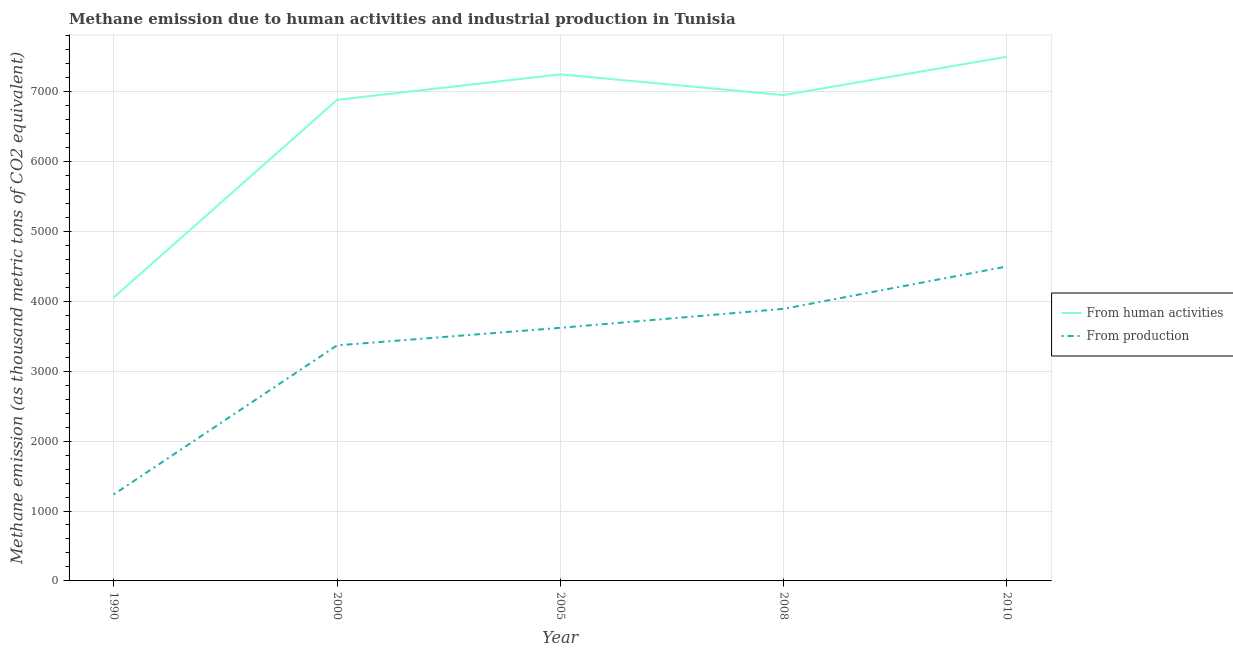What is the amount of emissions generated from industries in 2010?
Give a very brief answer. 4497.8. Across all years, what is the maximum amount of emissions generated from industries?
Give a very brief answer. 4497.8. Across all years, what is the minimum amount of emissions generated from industries?
Give a very brief answer. 1237. In which year was the amount of emissions from human activities maximum?
Your answer should be very brief. 2010. In which year was the amount of emissions from human activities minimum?
Make the answer very short. 1990. What is the total amount of emissions generated from industries in the graph?
Keep it short and to the point. 1.66e+04. What is the difference between the amount of emissions from human activities in 1990 and that in 2010?
Make the answer very short. -3442.5. What is the difference between the amount of emissions from human activities in 2010 and the amount of emissions generated from industries in 2005?
Provide a short and direct response. 3877.2. What is the average amount of emissions generated from industries per year?
Your response must be concise. 3323.08. In the year 2000, what is the difference between the amount of emissions from human activities and amount of emissions generated from industries?
Offer a terse response. 3511.7. In how many years, is the amount of emissions from human activities greater than 1800 thousand metric tons?
Your response must be concise. 5. What is the ratio of the amount of emissions generated from industries in 2005 to that in 2010?
Give a very brief answer. 0.8. What is the difference between the highest and the second highest amount of emissions from human activities?
Give a very brief answer. 251.9. What is the difference between the highest and the lowest amount of emissions from human activities?
Offer a terse response. 3442.5. Is the sum of the amount of emissions from human activities in 1990 and 2010 greater than the maximum amount of emissions generated from industries across all years?
Offer a very short reply. Yes. Is the amount of emissions generated from industries strictly less than the amount of emissions from human activities over the years?
Provide a short and direct response. Yes. What is the difference between two consecutive major ticks on the Y-axis?
Offer a terse response. 1000. Does the graph contain grids?
Your response must be concise. Yes. What is the title of the graph?
Your answer should be very brief. Methane emission due to human activities and industrial production in Tunisia. Does "Passenger Transport Items" appear as one of the legend labels in the graph?
Provide a short and direct response. No. What is the label or title of the Y-axis?
Your answer should be compact. Methane emission (as thousand metric tons of CO2 equivalent). What is the Methane emission (as thousand metric tons of CO2 equivalent) of From human activities in 1990?
Provide a short and direct response. 4054.8. What is the Methane emission (as thousand metric tons of CO2 equivalent) in From production in 1990?
Your answer should be compact. 1237. What is the Methane emission (as thousand metric tons of CO2 equivalent) in From human activities in 2000?
Offer a terse response. 6880.6. What is the Methane emission (as thousand metric tons of CO2 equivalent) in From production in 2000?
Offer a very short reply. 3368.9. What is the Methane emission (as thousand metric tons of CO2 equivalent) of From human activities in 2005?
Make the answer very short. 7245.4. What is the Methane emission (as thousand metric tons of CO2 equivalent) of From production in 2005?
Your answer should be very brief. 3620.1. What is the Methane emission (as thousand metric tons of CO2 equivalent) in From human activities in 2008?
Provide a short and direct response. 6949.3. What is the Methane emission (as thousand metric tons of CO2 equivalent) in From production in 2008?
Provide a short and direct response. 3891.6. What is the Methane emission (as thousand metric tons of CO2 equivalent) in From human activities in 2010?
Ensure brevity in your answer.  7497.3. What is the Methane emission (as thousand metric tons of CO2 equivalent) of From production in 2010?
Ensure brevity in your answer.  4497.8. Across all years, what is the maximum Methane emission (as thousand metric tons of CO2 equivalent) in From human activities?
Provide a short and direct response. 7497.3. Across all years, what is the maximum Methane emission (as thousand metric tons of CO2 equivalent) in From production?
Provide a short and direct response. 4497.8. Across all years, what is the minimum Methane emission (as thousand metric tons of CO2 equivalent) of From human activities?
Keep it short and to the point. 4054.8. Across all years, what is the minimum Methane emission (as thousand metric tons of CO2 equivalent) in From production?
Give a very brief answer. 1237. What is the total Methane emission (as thousand metric tons of CO2 equivalent) of From human activities in the graph?
Your answer should be compact. 3.26e+04. What is the total Methane emission (as thousand metric tons of CO2 equivalent) of From production in the graph?
Provide a short and direct response. 1.66e+04. What is the difference between the Methane emission (as thousand metric tons of CO2 equivalent) in From human activities in 1990 and that in 2000?
Your response must be concise. -2825.8. What is the difference between the Methane emission (as thousand metric tons of CO2 equivalent) in From production in 1990 and that in 2000?
Offer a very short reply. -2131.9. What is the difference between the Methane emission (as thousand metric tons of CO2 equivalent) in From human activities in 1990 and that in 2005?
Ensure brevity in your answer.  -3190.6. What is the difference between the Methane emission (as thousand metric tons of CO2 equivalent) of From production in 1990 and that in 2005?
Your answer should be compact. -2383.1. What is the difference between the Methane emission (as thousand metric tons of CO2 equivalent) of From human activities in 1990 and that in 2008?
Ensure brevity in your answer.  -2894.5. What is the difference between the Methane emission (as thousand metric tons of CO2 equivalent) in From production in 1990 and that in 2008?
Your answer should be compact. -2654.6. What is the difference between the Methane emission (as thousand metric tons of CO2 equivalent) of From human activities in 1990 and that in 2010?
Provide a short and direct response. -3442.5. What is the difference between the Methane emission (as thousand metric tons of CO2 equivalent) of From production in 1990 and that in 2010?
Give a very brief answer. -3260.8. What is the difference between the Methane emission (as thousand metric tons of CO2 equivalent) of From human activities in 2000 and that in 2005?
Provide a short and direct response. -364.8. What is the difference between the Methane emission (as thousand metric tons of CO2 equivalent) in From production in 2000 and that in 2005?
Your answer should be very brief. -251.2. What is the difference between the Methane emission (as thousand metric tons of CO2 equivalent) in From human activities in 2000 and that in 2008?
Your answer should be very brief. -68.7. What is the difference between the Methane emission (as thousand metric tons of CO2 equivalent) in From production in 2000 and that in 2008?
Your answer should be compact. -522.7. What is the difference between the Methane emission (as thousand metric tons of CO2 equivalent) in From human activities in 2000 and that in 2010?
Give a very brief answer. -616.7. What is the difference between the Methane emission (as thousand metric tons of CO2 equivalent) of From production in 2000 and that in 2010?
Provide a short and direct response. -1128.9. What is the difference between the Methane emission (as thousand metric tons of CO2 equivalent) of From human activities in 2005 and that in 2008?
Your answer should be compact. 296.1. What is the difference between the Methane emission (as thousand metric tons of CO2 equivalent) of From production in 2005 and that in 2008?
Provide a succinct answer. -271.5. What is the difference between the Methane emission (as thousand metric tons of CO2 equivalent) of From human activities in 2005 and that in 2010?
Make the answer very short. -251.9. What is the difference between the Methane emission (as thousand metric tons of CO2 equivalent) in From production in 2005 and that in 2010?
Offer a terse response. -877.7. What is the difference between the Methane emission (as thousand metric tons of CO2 equivalent) of From human activities in 2008 and that in 2010?
Your answer should be very brief. -548. What is the difference between the Methane emission (as thousand metric tons of CO2 equivalent) in From production in 2008 and that in 2010?
Ensure brevity in your answer.  -606.2. What is the difference between the Methane emission (as thousand metric tons of CO2 equivalent) of From human activities in 1990 and the Methane emission (as thousand metric tons of CO2 equivalent) of From production in 2000?
Give a very brief answer. 685.9. What is the difference between the Methane emission (as thousand metric tons of CO2 equivalent) in From human activities in 1990 and the Methane emission (as thousand metric tons of CO2 equivalent) in From production in 2005?
Your response must be concise. 434.7. What is the difference between the Methane emission (as thousand metric tons of CO2 equivalent) in From human activities in 1990 and the Methane emission (as thousand metric tons of CO2 equivalent) in From production in 2008?
Provide a succinct answer. 163.2. What is the difference between the Methane emission (as thousand metric tons of CO2 equivalent) in From human activities in 1990 and the Methane emission (as thousand metric tons of CO2 equivalent) in From production in 2010?
Your answer should be compact. -443. What is the difference between the Methane emission (as thousand metric tons of CO2 equivalent) of From human activities in 2000 and the Methane emission (as thousand metric tons of CO2 equivalent) of From production in 2005?
Keep it short and to the point. 3260.5. What is the difference between the Methane emission (as thousand metric tons of CO2 equivalent) of From human activities in 2000 and the Methane emission (as thousand metric tons of CO2 equivalent) of From production in 2008?
Offer a terse response. 2989. What is the difference between the Methane emission (as thousand metric tons of CO2 equivalent) of From human activities in 2000 and the Methane emission (as thousand metric tons of CO2 equivalent) of From production in 2010?
Ensure brevity in your answer.  2382.8. What is the difference between the Methane emission (as thousand metric tons of CO2 equivalent) in From human activities in 2005 and the Methane emission (as thousand metric tons of CO2 equivalent) in From production in 2008?
Provide a short and direct response. 3353.8. What is the difference between the Methane emission (as thousand metric tons of CO2 equivalent) of From human activities in 2005 and the Methane emission (as thousand metric tons of CO2 equivalent) of From production in 2010?
Ensure brevity in your answer.  2747.6. What is the difference between the Methane emission (as thousand metric tons of CO2 equivalent) of From human activities in 2008 and the Methane emission (as thousand metric tons of CO2 equivalent) of From production in 2010?
Offer a very short reply. 2451.5. What is the average Methane emission (as thousand metric tons of CO2 equivalent) in From human activities per year?
Your answer should be compact. 6525.48. What is the average Methane emission (as thousand metric tons of CO2 equivalent) of From production per year?
Your answer should be very brief. 3323.08. In the year 1990, what is the difference between the Methane emission (as thousand metric tons of CO2 equivalent) of From human activities and Methane emission (as thousand metric tons of CO2 equivalent) of From production?
Your answer should be very brief. 2817.8. In the year 2000, what is the difference between the Methane emission (as thousand metric tons of CO2 equivalent) in From human activities and Methane emission (as thousand metric tons of CO2 equivalent) in From production?
Make the answer very short. 3511.7. In the year 2005, what is the difference between the Methane emission (as thousand metric tons of CO2 equivalent) of From human activities and Methane emission (as thousand metric tons of CO2 equivalent) of From production?
Provide a short and direct response. 3625.3. In the year 2008, what is the difference between the Methane emission (as thousand metric tons of CO2 equivalent) of From human activities and Methane emission (as thousand metric tons of CO2 equivalent) of From production?
Ensure brevity in your answer.  3057.7. In the year 2010, what is the difference between the Methane emission (as thousand metric tons of CO2 equivalent) of From human activities and Methane emission (as thousand metric tons of CO2 equivalent) of From production?
Your answer should be very brief. 2999.5. What is the ratio of the Methane emission (as thousand metric tons of CO2 equivalent) of From human activities in 1990 to that in 2000?
Make the answer very short. 0.59. What is the ratio of the Methane emission (as thousand metric tons of CO2 equivalent) in From production in 1990 to that in 2000?
Provide a succinct answer. 0.37. What is the ratio of the Methane emission (as thousand metric tons of CO2 equivalent) in From human activities in 1990 to that in 2005?
Offer a terse response. 0.56. What is the ratio of the Methane emission (as thousand metric tons of CO2 equivalent) of From production in 1990 to that in 2005?
Ensure brevity in your answer.  0.34. What is the ratio of the Methane emission (as thousand metric tons of CO2 equivalent) of From human activities in 1990 to that in 2008?
Offer a terse response. 0.58. What is the ratio of the Methane emission (as thousand metric tons of CO2 equivalent) in From production in 1990 to that in 2008?
Keep it short and to the point. 0.32. What is the ratio of the Methane emission (as thousand metric tons of CO2 equivalent) of From human activities in 1990 to that in 2010?
Keep it short and to the point. 0.54. What is the ratio of the Methane emission (as thousand metric tons of CO2 equivalent) of From production in 1990 to that in 2010?
Ensure brevity in your answer.  0.28. What is the ratio of the Methane emission (as thousand metric tons of CO2 equivalent) in From human activities in 2000 to that in 2005?
Ensure brevity in your answer.  0.95. What is the ratio of the Methane emission (as thousand metric tons of CO2 equivalent) of From production in 2000 to that in 2005?
Offer a terse response. 0.93. What is the ratio of the Methane emission (as thousand metric tons of CO2 equivalent) of From production in 2000 to that in 2008?
Offer a terse response. 0.87. What is the ratio of the Methane emission (as thousand metric tons of CO2 equivalent) in From human activities in 2000 to that in 2010?
Your answer should be very brief. 0.92. What is the ratio of the Methane emission (as thousand metric tons of CO2 equivalent) in From production in 2000 to that in 2010?
Your answer should be very brief. 0.75. What is the ratio of the Methane emission (as thousand metric tons of CO2 equivalent) in From human activities in 2005 to that in 2008?
Give a very brief answer. 1.04. What is the ratio of the Methane emission (as thousand metric tons of CO2 equivalent) in From production in 2005 to that in 2008?
Provide a short and direct response. 0.93. What is the ratio of the Methane emission (as thousand metric tons of CO2 equivalent) of From human activities in 2005 to that in 2010?
Offer a terse response. 0.97. What is the ratio of the Methane emission (as thousand metric tons of CO2 equivalent) in From production in 2005 to that in 2010?
Offer a very short reply. 0.8. What is the ratio of the Methane emission (as thousand metric tons of CO2 equivalent) of From human activities in 2008 to that in 2010?
Offer a terse response. 0.93. What is the ratio of the Methane emission (as thousand metric tons of CO2 equivalent) of From production in 2008 to that in 2010?
Provide a short and direct response. 0.87. What is the difference between the highest and the second highest Methane emission (as thousand metric tons of CO2 equivalent) of From human activities?
Your answer should be compact. 251.9. What is the difference between the highest and the second highest Methane emission (as thousand metric tons of CO2 equivalent) in From production?
Provide a short and direct response. 606.2. What is the difference between the highest and the lowest Methane emission (as thousand metric tons of CO2 equivalent) in From human activities?
Make the answer very short. 3442.5. What is the difference between the highest and the lowest Methane emission (as thousand metric tons of CO2 equivalent) of From production?
Your answer should be very brief. 3260.8. 